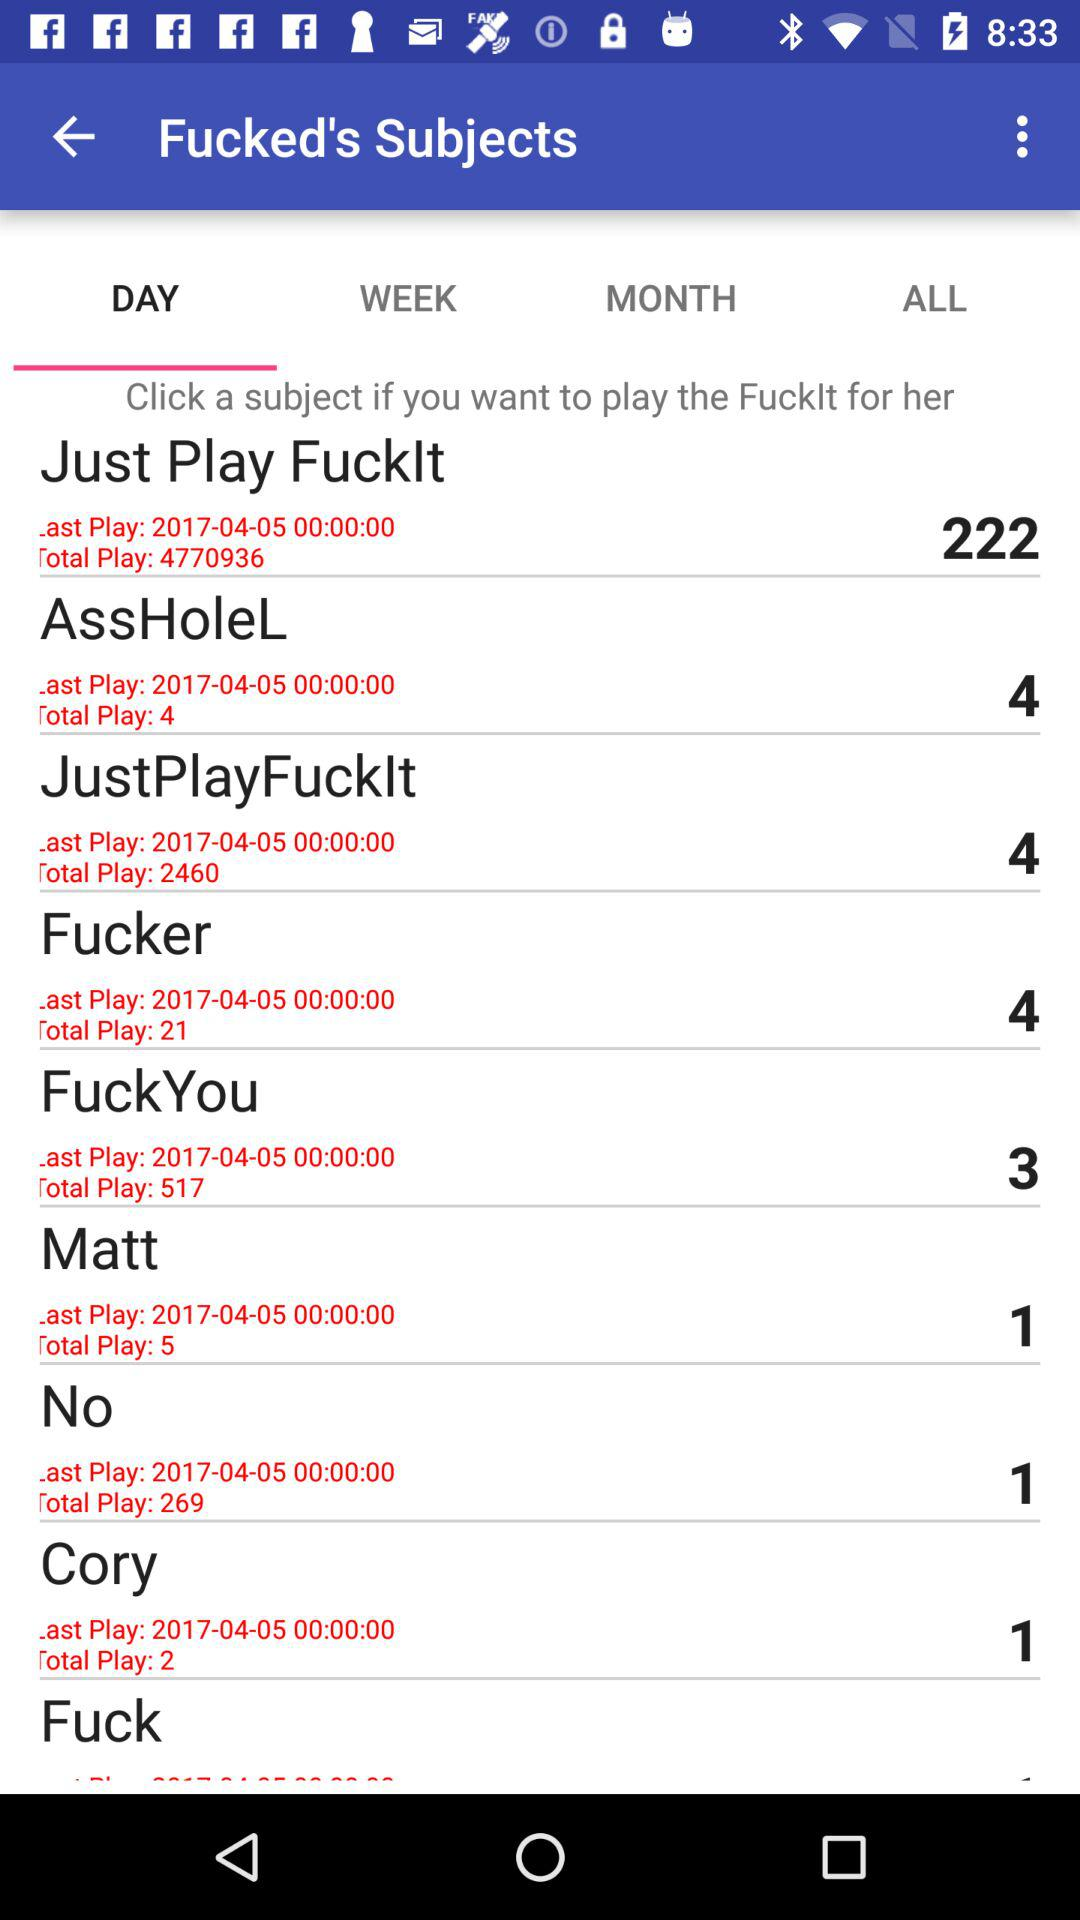What is the score of just playing fucklt?
When the provided information is insufficient, respond with <no answer>. <no answer> 